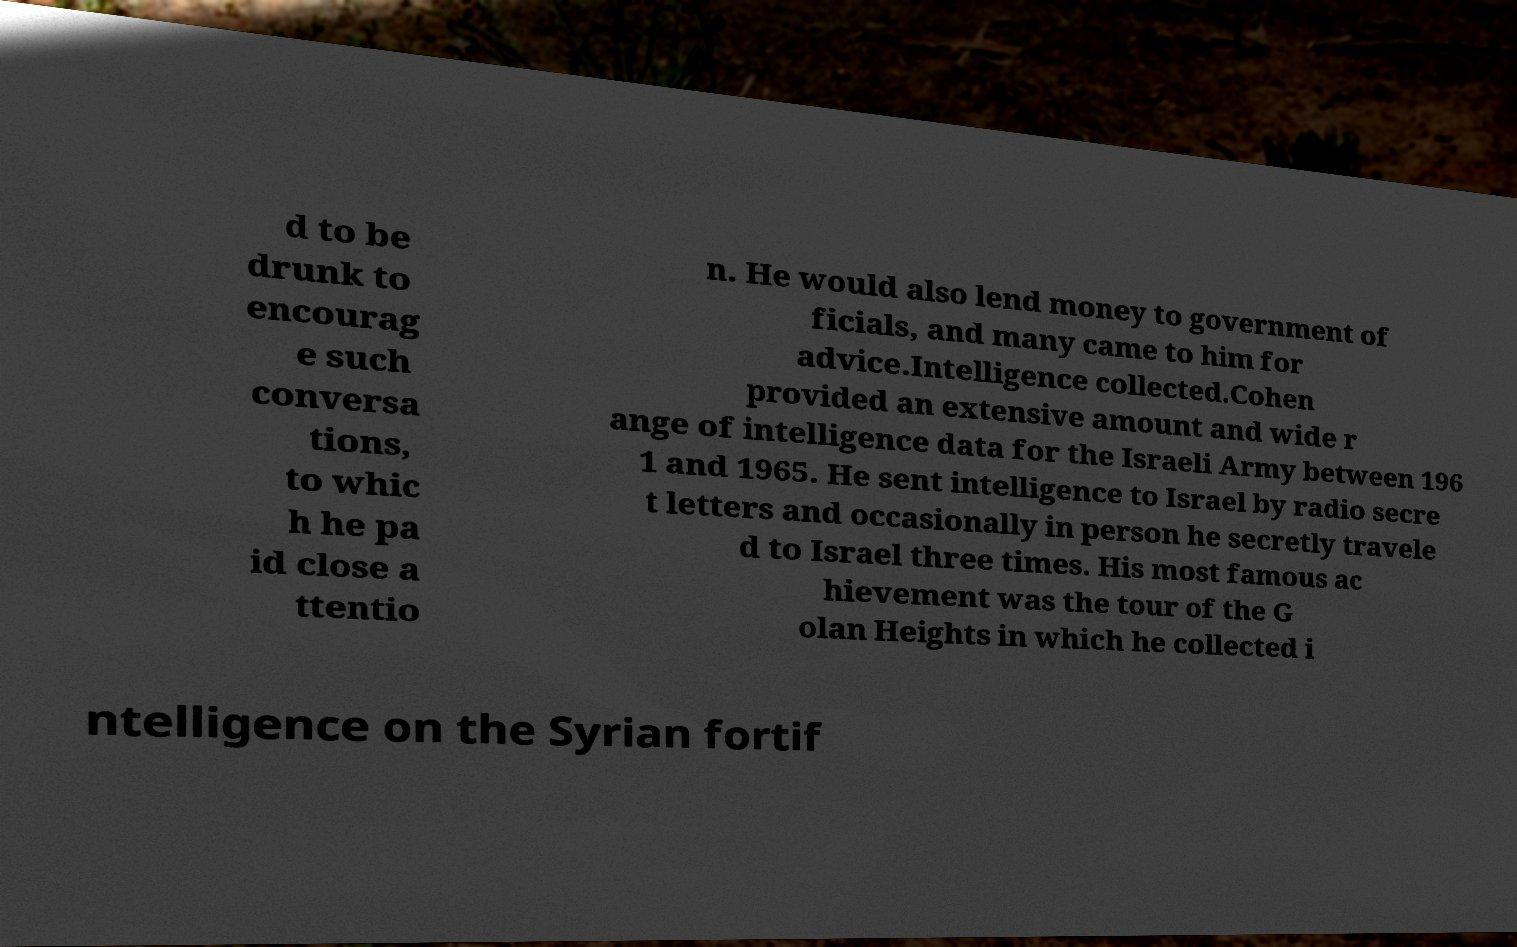Could you assist in decoding the text presented in this image and type it out clearly? d to be drunk to encourag e such conversa tions, to whic h he pa id close a ttentio n. He would also lend money to government of ficials, and many came to him for advice.Intelligence collected.Cohen provided an extensive amount and wide r ange of intelligence data for the Israeli Army between 196 1 and 1965. He sent intelligence to Israel by radio secre t letters and occasionally in person he secretly travele d to Israel three times. His most famous ac hievement was the tour of the G olan Heights in which he collected i ntelligence on the Syrian fortif 